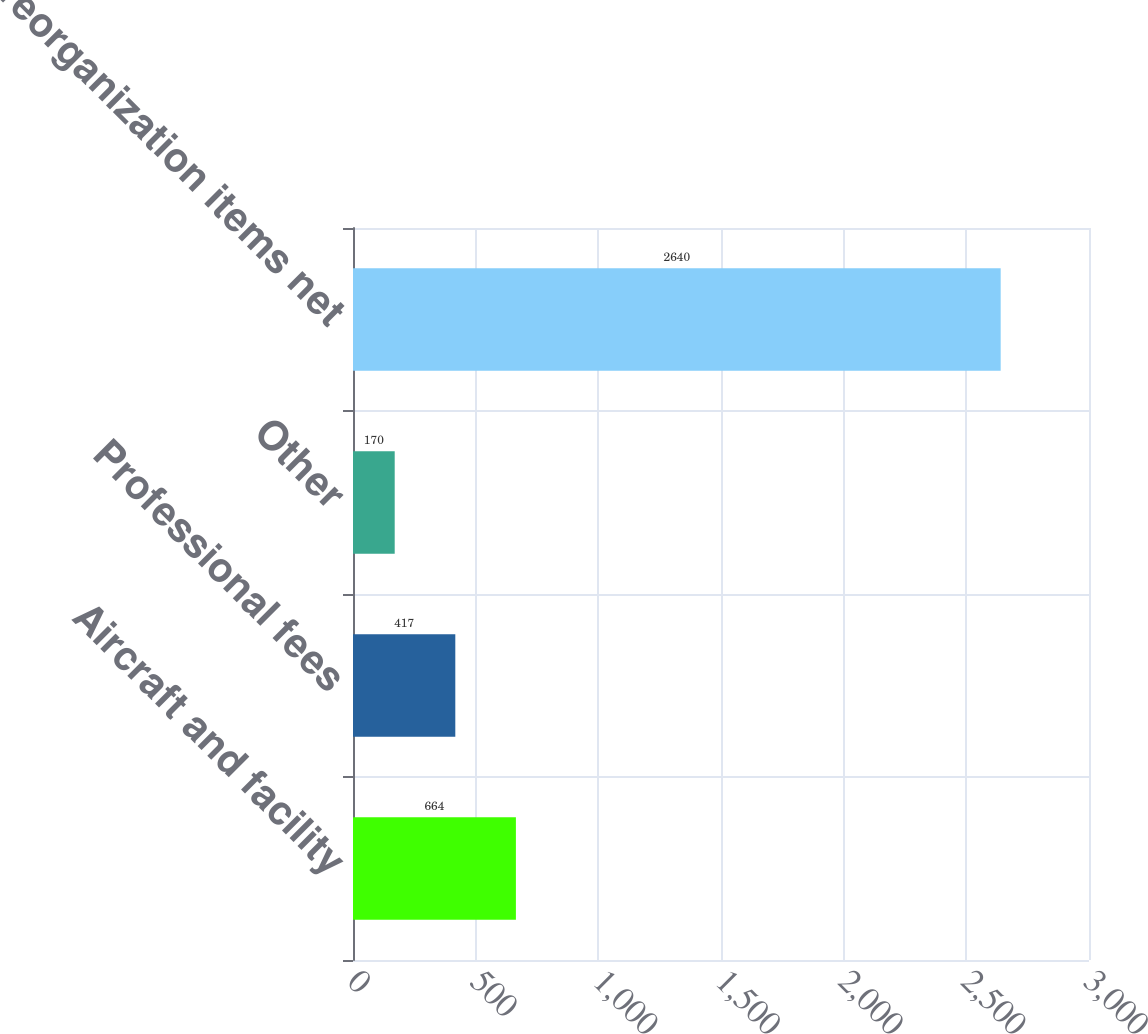Convert chart. <chart><loc_0><loc_0><loc_500><loc_500><bar_chart><fcel>Aircraft and facility<fcel>Professional fees<fcel>Other<fcel>Total reorganization items net<nl><fcel>664<fcel>417<fcel>170<fcel>2640<nl></chart> 